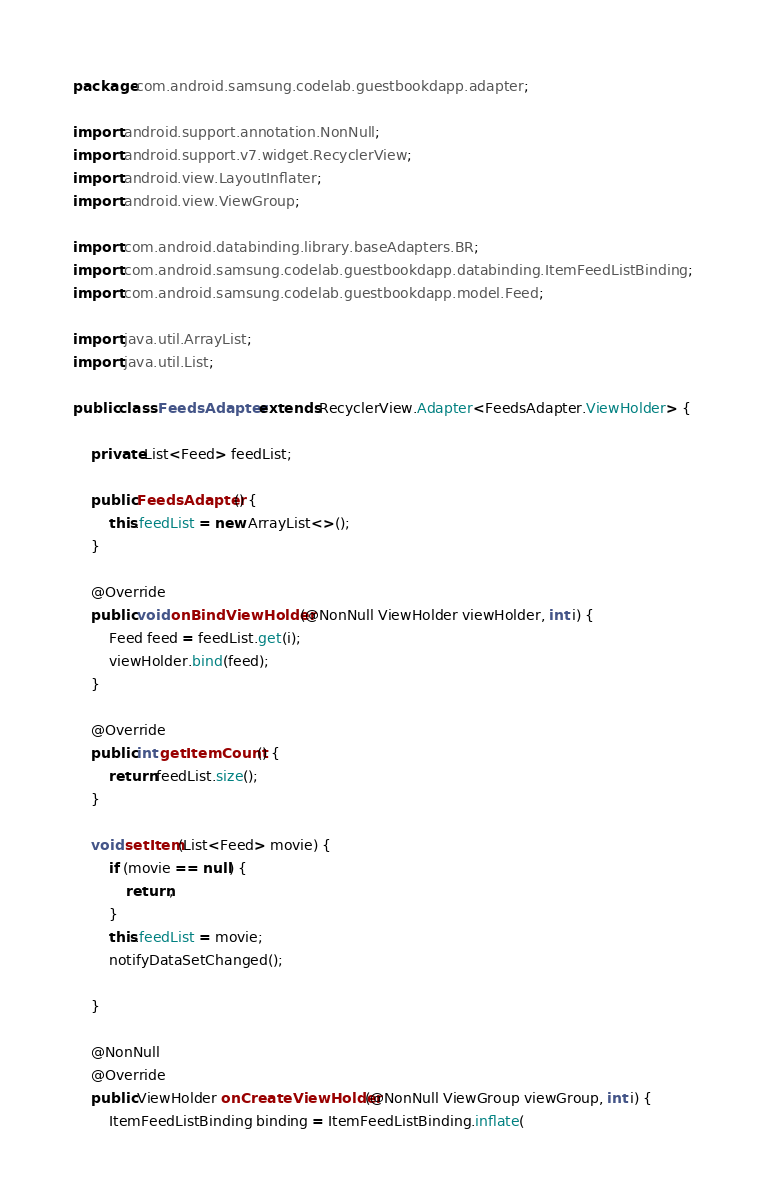Convert code to text. <code><loc_0><loc_0><loc_500><loc_500><_Java_>package com.android.samsung.codelab.guestbookdapp.adapter;

import android.support.annotation.NonNull;
import android.support.v7.widget.RecyclerView;
import android.view.LayoutInflater;
import android.view.ViewGroup;

import com.android.databinding.library.baseAdapters.BR;
import com.android.samsung.codelab.guestbookdapp.databinding.ItemFeedListBinding;
import com.android.samsung.codelab.guestbookdapp.model.Feed;

import java.util.ArrayList;
import java.util.List;

public class FeedsAdapter extends RecyclerView.Adapter<FeedsAdapter.ViewHolder> {

    private List<Feed> feedList;

    public FeedsAdapter() {
        this.feedList = new ArrayList<>();
    }

    @Override
    public void onBindViewHolder(@NonNull ViewHolder viewHolder, int i) {
        Feed feed = feedList.get(i);
        viewHolder.bind(feed);
    }

    @Override
    public int getItemCount() {
        return feedList.size();
    }

    void setItem(List<Feed> movie) {
        if (movie == null) {
            return;
        }
        this.feedList = movie;
        notifyDataSetChanged();

    }

    @NonNull
    @Override
    public ViewHolder onCreateViewHolder(@NonNull ViewGroup viewGroup, int i) {
        ItemFeedListBinding binding = ItemFeedListBinding.inflate(</code> 